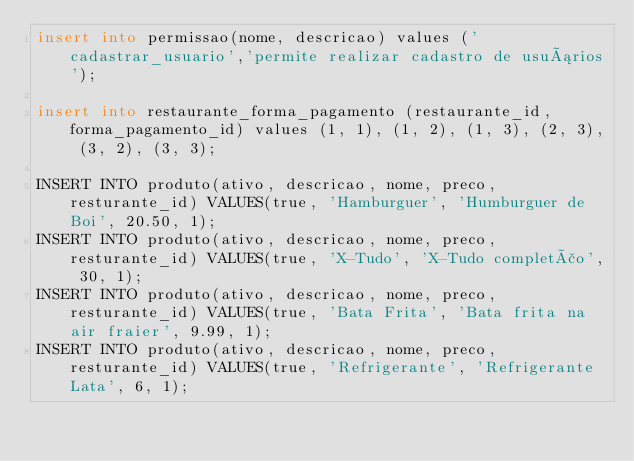<code> <loc_0><loc_0><loc_500><loc_500><_SQL_>insert into permissao(nome, descricao) values ('cadastrar_usuario','permite realizar cadastro de usuários');

insert into restaurante_forma_pagamento (restaurante_id, forma_pagamento_id) values (1, 1), (1, 2), (1, 3), (2, 3), (3, 2), (3, 3);

INSERT INTO produto(ativo, descricao, nome, preco, resturante_id) VALUES(true, 'Hamburguer', 'Humburguer de Boi', 20.50, 1);
INSERT INTO produto(ativo, descricao, nome, preco, resturante_id) VALUES(true, 'X-Tudo', 'X-Tudo completão', 30, 1);
INSERT INTO produto(ativo, descricao, nome, preco, resturante_id) VALUES(true, 'Bata Frita', 'Bata frita na air fraier', 9.99, 1);
INSERT INTO produto(ativo, descricao, nome, preco, resturante_id) VALUES(true, 'Refrigerante', 'Refrigerante Lata', 6, 1);
</code> 